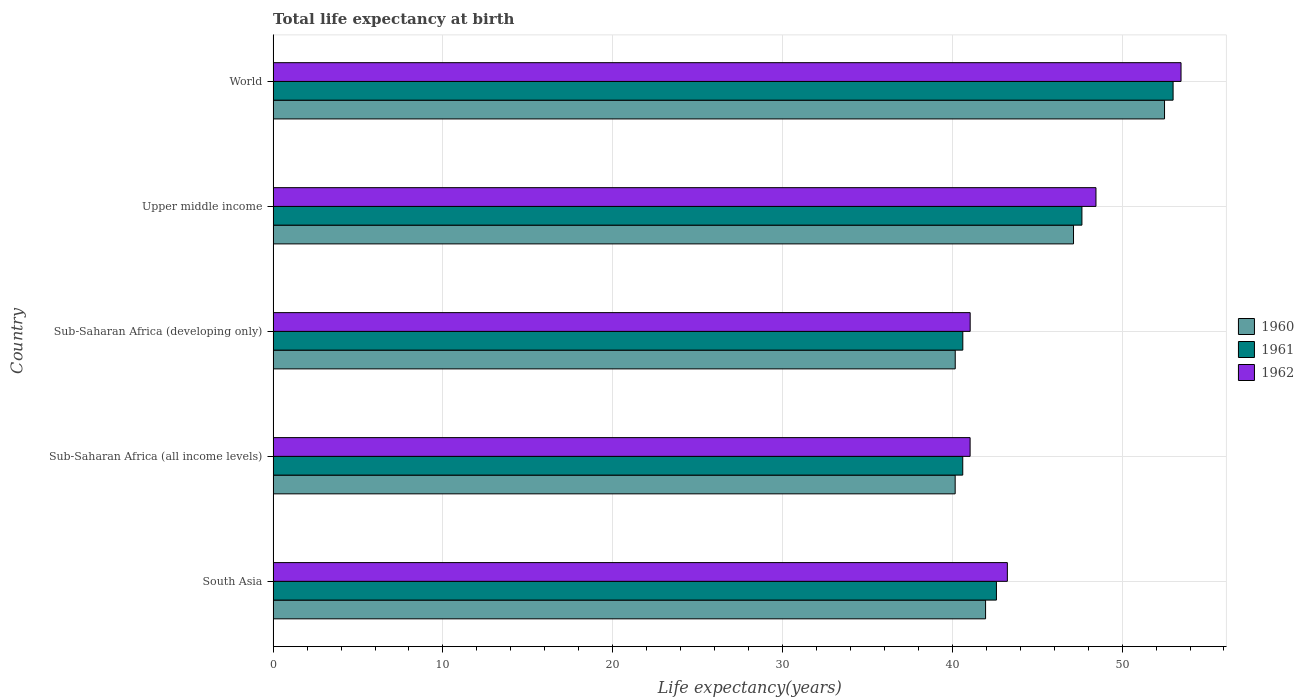How many groups of bars are there?
Keep it short and to the point. 5. How many bars are there on the 5th tick from the top?
Ensure brevity in your answer.  3. How many bars are there on the 4th tick from the bottom?
Give a very brief answer. 3. What is the label of the 4th group of bars from the top?
Make the answer very short. Sub-Saharan Africa (all income levels). In how many cases, is the number of bars for a given country not equal to the number of legend labels?
Provide a short and direct response. 0. What is the life expectancy at birth in in 1960 in South Asia?
Keep it short and to the point. 41.96. Across all countries, what is the maximum life expectancy at birth in in 1961?
Your answer should be compact. 53. Across all countries, what is the minimum life expectancy at birth in in 1960?
Your answer should be very brief. 40.17. In which country was the life expectancy at birth in in 1960 minimum?
Your answer should be compact. Sub-Saharan Africa (all income levels). What is the total life expectancy at birth in in 1961 in the graph?
Your response must be concise. 224.47. What is the difference between the life expectancy at birth in in 1962 in South Asia and that in Sub-Saharan Africa (all income levels)?
Keep it short and to the point. 2.19. What is the difference between the life expectancy at birth in in 1961 in Upper middle income and the life expectancy at birth in in 1960 in Sub-Saharan Africa (all income levels)?
Your response must be concise. 7.47. What is the average life expectancy at birth in in 1962 per country?
Offer a very short reply. 45.46. What is the difference between the life expectancy at birth in in 1962 and life expectancy at birth in in 1961 in Upper middle income?
Your answer should be very brief. 0.83. What is the ratio of the life expectancy at birth in in 1961 in South Asia to that in Sub-Saharan Africa (developing only)?
Offer a very short reply. 1.05. Is the life expectancy at birth in in 1961 in Sub-Saharan Africa (all income levels) less than that in Upper middle income?
Your answer should be compact. Yes. What is the difference between the highest and the second highest life expectancy at birth in in 1962?
Keep it short and to the point. 5.01. What is the difference between the highest and the lowest life expectancy at birth in in 1962?
Your answer should be very brief. 12.42. In how many countries, is the life expectancy at birth in in 1960 greater than the average life expectancy at birth in in 1960 taken over all countries?
Ensure brevity in your answer.  2. Is the sum of the life expectancy at birth in in 1961 in Sub-Saharan Africa (all income levels) and World greater than the maximum life expectancy at birth in in 1962 across all countries?
Make the answer very short. Yes. What does the 1st bar from the top in Upper middle income represents?
Your answer should be very brief. 1962. What does the 3rd bar from the bottom in World represents?
Offer a terse response. 1962. How many bars are there?
Make the answer very short. 15. How many countries are there in the graph?
Ensure brevity in your answer.  5. What is the difference between two consecutive major ticks on the X-axis?
Your answer should be compact. 10. Does the graph contain grids?
Keep it short and to the point. Yes. How many legend labels are there?
Give a very brief answer. 3. What is the title of the graph?
Make the answer very short. Total life expectancy at birth. What is the label or title of the X-axis?
Your response must be concise. Life expectancy(years). What is the Life expectancy(years) in 1960 in South Asia?
Your response must be concise. 41.96. What is the Life expectancy(years) in 1961 in South Asia?
Keep it short and to the point. 42.6. What is the Life expectancy(years) in 1962 in South Asia?
Give a very brief answer. 43.24. What is the Life expectancy(years) of 1960 in Sub-Saharan Africa (all income levels)?
Offer a very short reply. 40.17. What is the Life expectancy(years) in 1961 in Sub-Saharan Africa (all income levels)?
Provide a short and direct response. 40.62. What is the Life expectancy(years) in 1962 in Sub-Saharan Africa (all income levels)?
Provide a short and direct response. 41.05. What is the Life expectancy(years) of 1960 in Sub-Saharan Africa (developing only)?
Keep it short and to the point. 40.17. What is the Life expectancy(years) of 1961 in Sub-Saharan Africa (developing only)?
Keep it short and to the point. 40.62. What is the Life expectancy(years) of 1962 in Sub-Saharan Africa (developing only)?
Keep it short and to the point. 41.05. What is the Life expectancy(years) of 1960 in Upper middle income?
Keep it short and to the point. 47.14. What is the Life expectancy(years) in 1961 in Upper middle income?
Offer a terse response. 47.63. What is the Life expectancy(years) of 1962 in Upper middle income?
Offer a terse response. 48.46. What is the Life expectancy(years) in 1960 in World?
Your answer should be compact. 52.5. What is the Life expectancy(years) of 1961 in World?
Provide a short and direct response. 53. What is the Life expectancy(years) in 1962 in World?
Offer a terse response. 53.47. Across all countries, what is the maximum Life expectancy(years) of 1960?
Keep it short and to the point. 52.5. Across all countries, what is the maximum Life expectancy(years) in 1961?
Provide a short and direct response. 53. Across all countries, what is the maximum Life expectancy(years) in 1962?
Offer a terse response. 53.47. Across all countries, what is the minimum Life expectancy(years) of 1960?
Provide a succinct answer. 40.17. Across all countries, what is the minimum Life expectancy(years) in 1961?
Your response must be concise. 40.62. Across all countries, what is the minimum Life expectancy(years) in 1962?
Your response must be concise. 41.05. What is the total Life expectancy(years) of 1960 in the graph?
Ensure brevity in your answer.  221.94. What is the total Life expectancy(years) in 1961 in the graph?
Ensure brevity in your answer.  224.47. What is the total Life expectancy(years) in 1962 in the graph?
Provide a short and direct response. 227.28. What is the difference between the Life expectancy(years) of 1960 in South Asia and that in Sub-Saharan Africa (all income levels)?
Your answer should be compact. 1.79. What is the difference between the Life expectancy(years) in 1961 in South Asia and that in Sub-Saharan Africa (all income levels)?
Your answer should be compact. 1.98. What is the difference between the Life expectancy(years) of 1962 in South Asia and that in Sub-Saharan Africa (all income levels)?
Provide a short and direct response. 2.19. What is the difference between the Life expectancy(years) in 1960 in South Asia and that in Sub-Saharan Africa (developing only)?
Offer a terse response. 1.79. What is the difference between the Life expectancy(years) in 1961 in South Asia and that in Sub-Saharan Africa (developing only)?
Offer a terse response. 1.98. What is the difference between the Life expectancy(years) of 1962 in South Asia and that in Sub-Saharan Africa (developing only)?
Provide a succinct answer. 2.19. What is the difference between the Life expectancy(years) in 1960 in South Asia and that in Upper middle income?
Provide a short and direct response. -5.18. What is the difference between the Life expectancy(years) of 1961 in South Asia and that in Upper middle income?
Provide a short and direct response. -5.03. What is the difference between the Life expectancy(years) in 1962 in South Asia and that in Upper middle income?
Your answer should be compact. -5.22. What is the difference between the Life expectancy(years) of 1960 in South Asia and that in World?
Make the answer very short. -10.54. What is the difference between the Life expectancy(years) in 1961 in South Asia and that in World?
Ensure brevity in your answer.  -10.4. What is the difference between the Life expectancy(years) of 1962 in South Asia and that in World?
Your answer should be compact. -10.23. What is the difference between the Life expectancy(years) in 1960 in Sub-Saharan Africa (all income levels) and that in Sub-Saharan Africa (developing only)?
Your answer should be very brief. -0. What is the difference between the Life expectancy(years) of 1961 in Sub-Saharan Africa (all income levels) and that in Sub-Saharan Africa (developing only)?
Your answer should be compact. -0. What is the difference between the Life expectancy(years) in 1962 in Sub-Saharan Africa (all income levels) and that in Sub-Saharan Africa (developing only)?
Ensure brevity in your answer.  -0. What is the difference between the Life expectancy(years) in 1960 in Sub-Saharan Africa (all income levels) and that in Upper middle income?
Keep it short and to the point. -6.97. What is the difference between the Life expectancy(years) in 1961 in Sub-Saharan Africa (all income levels) and that in Upper middle income?
Provide a short and direct response. -7.02. What is the difference between the Life expectancy(years) in 1962 in Sub-Saharan Africa (all income levels) and that in Upper middle income?
Your response must be concise. -7.41. What is the difference between the Life expectancy(years) of 1960 in Sub-Saharan Africa (all income levels) and that in World?
Your answer should be very brief. -12.33. What is the difference between the Life expectancy(years) in 1961 in Sub-Saharan Africa (all income levels) and that in World?
Offer a terse response. -12.39. What is the difference between the Life expectancy(years) in 1962 in Sub-Saharan Africa (all income levels) and that in World?
Make the answer very short. -12.42. What is the difference between the Life expectancy(years) of 1960 in Sub-Saharan Africa (developing only) and that in Upper middle income?
Offer a very short reply. -6.97. What is the difference between the Life expectancy(years) in 1961 in Sub-Saharan Africa (developing only) and that in Upper middle income?
Ensure brevity in your answer.  -7.02. What is the difference between the Life expectancy(years) in 1962 in Sub-Saharan Africa (developing only) and that in Upper middle income?
Your answer should be compact. -7.41. What is the difference between the Life expectancy(years) in 1960 in Sub-Saharan Africa (developing only) and that in World?
Make the answer very short. -12.33. What is the difference between the Life expectancy(years) of 1961 in Sub-Saharan Africa (developing only) and that in World?
Provide a short and direct response. -12.38. What is the difference between the Life expectancy(years) of 1962 in Sub-Saharan Africa (developing only) and that in World?
Provide a short and direct response. -12.42. What is the difference between the Life expectancy(years) in 1960 in Upper middle income and that in World?
Keep it short and to the point. -5.36. What is the difference between the Life expectancy(years) of 1961 in Upper middle income and that in World?
Provide a short and direct response. -5.37. What is the difference between the Life expectancy(years) of 1962 in Upper middle income and that in World?
Make the answer very short. -5.01. What is the difference between the Life expectancy(years) of 1960 in South Asia and the Life expectancy(years) of 1961 in Sub-Saharan Africa (all income levels)?
Your answer should be very brief. 1.34. What is the difference between the Life expectancy(years) in 1960 in South Asia and the Life expectancy(years) in 1962 in Sub-Saharan Africa (all income levels)?
Give a very brief answer. 0.91. What is the difference between the Life expectancy(years) in 1961 in South Asia and the Life expectancy(years) in 1962 in Sub-Saharan Africa (all income levels)?
Make the answer very short. 1.55. What is the difference between the Life expectancy(years) in 1960 in South Asia and the Life expectancy(years) in 1961 in Sub-Saharan Africa (developing only)?
Provide a succinct answer. 1.34. What is the difference between the Life expectancy(years) in 1960 in South Asia and the Life expectancy(years) in 1962 in Sub-Saharan Africa (developing only)?
Give a very brief answer. 0.91. What is the difference between the Life expectancy(years) in 1961 in South Asia and the Life expectancy(years) in 1962 in Sub-Saharan Africa (developing only)?
Provide a succinct answer. 1.55. What is the difference between the Life expectancy(years) of 1960 in South Asia and the Life expectancy(years) of 1961 in Upper middle income?
Make the answer very short. -5.67. What is the difference between the Life expectancy(years) in 1960 in South Asia and the Life expectancy(years) in 1962 in Upper middle income?
Give a very brief answer. -6.5. What is the difference between the Life expectancy(years) in 1961 in South Asia and the Life expectancy(years) in 1962 in Upper middle income?
Offer a terse response. -5.86. What is the difference between the Life expectancy(years) in 1960 in South Asia and the Life expectancy(years) in 1961 in World?
Keep it short and to the point. -11.04. What is the difference between the Life expectancy(years) of 1960 in South Asia and the Life expectancy(years) of 1962 in World?
Keep it short and to the point. -11.51. What is the difference between the Life expectancy(years) in 1961 in South Asia and the Life expectancy(years) in 1962 in World?
Offer a very short reply. -10.87. What is the difference between the Life expectancy(years) in 1960 in Sub-Saharan Africa (all income levels) and the Life expectancy(years) in 1961 in Sub-Saharan Africa (developing only)?
Offer a terse response. -0.45. What is the difference between the Life expectancy(years) of 1960 in Sub-Saharan Africa (all income levels) and the Life expectancy(years) of 1962 in Sub-Saharan Africa (developing only)?
Your response must be concise. -0.88. What is the difference between the Life expectancy(years) of 1961 in Sub-Saharan Africa (all income levels) and the Life expectancy(years) of 1962 in Sub-Saharan Africa (developing only)?
Your response must be concise. -0.44. What is the difference between the Life expectancy(years) of 1960 in Sub-Saharan Africa (all income levels) and the Life expectancy(years) of 1961 in Upper middle income?
Offer a terse response. -7.46. What is the difference between the Life expectancy(years) in 1960 in Sub-Saharan Africa (all income levels) and the Life expectancy(years) in 1962 in Upper middle income?
Give a very brief answer. -8.29. What is the difference between the Life expectancy(years) in 1961 in Sub-Saharan Africa (all income levels) and the Life expectancy(years) in 1962 in Upper middle income?
Give a very brief answer. -7.85. What is the difference between the Life expectancy(years) in 1960 in Sub-Saharan Africa (all income levels) and the Life expectancy(years) in 1961 in World?
Ensure brevity in your answer.  -12.83. What is the difference between the Life expectancy(years) of 1960 in Sub-Saharan Africa (all income levels) and the Life expectancy(years) of 1962 in World?
Provide a short and direct response. -13.3. What is the difference between the Life expectancy(years) of 1961 in Sub-Saharan Africa (all income levels) and the Life expectancy(years) of 1962 in World?
Ensure brevity in your answer.  -12.86. What is the difference between the Life expectancy(years) of 1960 in Sub-Saharan Africa (developing only) and the Life expectancy(years) of 1961 in Upper middle income?
Ensure brevity in your answer.  -7.46. What is the difference between the Life expectancy(years) in 1960 in Sub-Saharan Africa (developing only) and the Life expectancy(years) in 1962 in Upper middle income?
Offer a very short reply. -8.29. What is the difference between the Life expectancy(years) of 1961 in Sub-Saharan Africa (developing only) and the Life expectancy(years) of 1962 in Upper middle income?
Provide a succinct answer. -7.84. What is the difference between the Life expectancy(years) in 1960 in Sub-Saharan Africa (developing only) and the Life expectancy(years) in 1961 in World?
Provide a short and direct response. -12.83. What is the difference between the Life expectancy(years) of 1960 in Sub-Saharan Africa (developing only) and the Life expectancy(years) of 1962 in World?
Keep it short and to the point. -13.3. What is the difference between the Life expectancy(years) in 1961 in Sub-Saharan Africa (developing only) and the Life expectancy(years) in 1962 in World?
Ensure brevity in your answer.  -12.85. What is the difference between the Life expectancy(years) in 1960 in Upper middle income and the Life expectancy(years) in 1961 in World?
Your answer should be compact. -5.86. What is the difference between the Life expectancy(years) of 1960 in Upper middle income and the Life expectancy(years) of 1962 in World?
Your response must be concise. -6.33. What is the difference between the Life expectancy(years) of 1961 in Upper middle income and the Life expectancy(years) of 1962 in World?
Your answer should be very brief. -5.84. What is the average Life expectancy(years) of 1960 per country?
Provide a succinct answer. 44.39. What is the average Life expectancy(years) of 1961 per country?
Offer a very short reply. 44.89. What is the average Life expectancy(years) of 1962 per country?
Provide a short and direct response. 45.46. What is the difference between the Life expectancy(years) of 1960 and Life expectancy(years) of 1961 in South Asia?
Provide a short and direct response. -0.64. What is the difference between the Life expectancy(years) in 1960 and Life expectancy(years) in 1962 in South Asia?
Your response must be concise. -1.28. What is the difference between the Life expectancy(years) in 1961 and Life expectancy(years) in 1962 in South Asia?
Offer a very short reply. -0.64. What is the difference between the Life expectancy(years) of 1960 and Life expectancy(years) of 1961 in Sub-Saharan Africa (all income levels)?
Give a very brief answer. -0.45. What is the difference between the Life expectancy(years) in 1960 and Life expectancy(years) in 1962 in Sub-Saharan Africa (all income levels)?
Your answer should be very brief. -0.88. What is the difference between the Life expectancy(years) in 1961 and Life expectancy(years) in 1962 in Sub-Saharan Africa (all income levels)?
Give a very brief answer. -0.43. What is the difference between the Life expectancy(years) of 1960 and Life expectancy(years) of 1961 in Sub-Saharan Africa (developing only)?
Make the answer very short. -0.45. What is the difference between the Life expectancy(years) of 1960 and Life expectancy(years) of 1962 in Sub-Saharan Africa (developing only)?
Your answer should be compact. -0.88. What is the difference between the Life expectancy(years) of 1961 and Life expectancy(years) of 1962 in Sub-Saharan Africa (developing only)?
Your answer should be compact. -0.43. What is the difference between the Life expectancy(years) in 1960 and Life expectancy(years) in 1961 in Upper middle income?
Your answer should be compact. -0.5. What is the difference between the Life expectancy(years) of 1960 and Life expectancy(years) of 1962 in Upper middle income?
Your answer should be very brief. -1.32. What is the difference between the Life expectancy(years) in 1961 and Life expectancy(years) in 1962 in Upper middle income?
Your answer should be compact. -0.83. What is the difference between the Life expectancy(years) in 1960 and Life expectancy(years) in 1961 in World?
Ensure brevity in your answer.  -0.5. What is the difference between the Life expectancy(years) in 1960 and Life expectancy(years) in 1962 in World?
Your answer should be very brief. -0.97. What is the difference between the Life expectancy(years) in 1961 and Life expectancy(years) in 1962 in World?
Your answer should be compact. -0.47. What is the ratio of the Life expectancy(years) of 1960 in South Asia to that in Sub-Saharan Africa (all income levels)?
Keep it short and to the point. 1.04. What is the ratio of the Life expectancy(years) of 1961 in South Asia to that in Sub-Saharan Africa (all income levels)?
Your answer should be very brief. 1.05. What is the ratio of the Life expectancy(years) of 1962 in South Asia to that in Sub-Saharan Africa (all income levels)?
Provide a short and direct response. 1.05. What is the ratio of the Life expectancy(years) in 1960 in South Asia to that in Sub-Saharan Africa (developing only)?
Keep it short and to the point. 1.04. What is the ratio of the Life expectancy(years) in 1961 in South Asia to that in Sub-Saharan Africa (developing only)?
Your answer should be compact. 1.05. What is the ratio of the Life expectancy(years) of 1962 in South Asia to that in Sub-Saharan Africa (developing only)?
Your response must be concise. 1.05. What is the ratio of the Life expectancy(years) in 1960 in South Asia to that in Upper middle income?
Provide a succinct answer. 0.89. What is the ratio of the Life expectancy(years) of 1961 in South Asia to that in Upper middle income?
Make the answer very short. 0.89. What is the ratio of the Life expectancy(years) of 1962 in South Asia to that in Upper middle income?
Make the answer very short. 0.89. What is the ratio of the Life expectancy(years) of 1960 in South Asia to that in World?
Provide a short and direct response. 0.8. What is the ratio of the Life expectancy(years) of 1961 in South Asia to that in World?
Provide a short and direct response. 0.8. What is the ratio of the Life expectancy(years) of 1962 in South Asia to that in World?
Your answer should be compact. 0.81. What is the ratio of the Life expectancy(years) of 1960 in Sub-Saharan Africa (all income levels) to that in Sub-Saharan Africa (developing only)?
Keep it short and to the point. 1. What is the ratio of the Life expectancy(years) of 1961 in Sub-Saharan Africa (all income levels) to that in Sub-Saharan Africa (developing only)?
Make the answer very short. 1. What is the ratio of the Life expectancy(years) of 1962 in Sub-Saharan Africa (all income levels) to that in Sub-Saharan Africa (developing only)?
Provide a succinct answer. 1. What is the ratio of the Life expectancy(years) of 1960 in Sub-Saharan Africa (all income levels) to that in Upper middle income?
Offer a very short reply. 0.85. What is the ratio of the Life expectancy(years) of 1961 in Sub-Saharan Africa (all income levels) to that in Upper middle income?
Your answer should be very brief. 0.85. What is the ratio of the Life expectancy(years) of 1962 in Sub-Saharan Africa (all income levels) to that in Upper middle income?
Offer a terse response. 0.85. What is the ratio of the Life expectancy(years) in 1960 in Sub-Saharan Africa (all income levels) to that in World?
Your answer should be compact. 0.77. What is the ratio of the Life expectancy(years) of 1961 in Sub-Saharan Africa (all income levels) to that in World?
Offer a very short reply. 0.77. What is the ratio of the Life expectancy(years) of 1962 in Sub-Saharan Africa (all income levels) to that in World?
Your answer should be very brief. 0.77. What is the ratio of the Life expectancy(years) in 1960 in Sub-Saharan Africa (developing only) to that in Upper middle income?
Your answer should be compact. 0.85. What is the ratio of the Life expectancy(years) of 1961 in Sub-Saharan Africa (developing only) to that in Upper middle income?
Your response must be concise. 0.85. What is the ratio of the Life expectancy(years) of 1962 in Sub-Saharan Africa (developing only) to that in Upper middle income?
Offer a very short reply. 0.85. What is the ratio of the Life expectancy(years) of 1960 in Sub-Saharan Africa (developing only) to that in World?
Provide a short and direct response. 0.77. What is the ratio of the Life expectancy(years) of 1961 in Sub-Saharan Africa (developing only) to that in World?
Keep it short and to the point. 0.77. What is the ratio of the Life expectancy(years) of 1962 in Sub-Saharan Africa (developing only) to that in World?
Offer a terse response. 0.77. What is the ratio of the Life expectancy(years) in 1960 in Upper middle income to that in World?
Provide a short and direct response. 0.9. What is the ratio of the Life expectancy(years) of 1961 in Upper middle income to that in World?
Give a very brief answer. 0.9. What is the ratio of the Life expectancy(years) in 1962 in Upper middle income to that in World?
Provide a short and direct response. 0.91. What is the difference between the highest and the second highest Life expectancy(years) in 1960?
Provide a succinct answer. 5.36. What is the difference between the highest and the second highest Life expectancy(years) of 1961?
Keep it short and to the point. 5.37. What is the difference between the highest and the second highest Life expectancy(years) of 1962?
Your response must be concise. 5.01. What is the difference between the highest and the lowest Life expectancy(years) of 1960?
Your answer should be very brief. 12.33. What is the difference between the highest and the lowest Life expectancy(years) of 1961?
Offer a terse response. 12.39. What is the difference between the highest and the lowest Life expectancy(years) in 1962?
Ensure brevity in your answer.  12.42. 